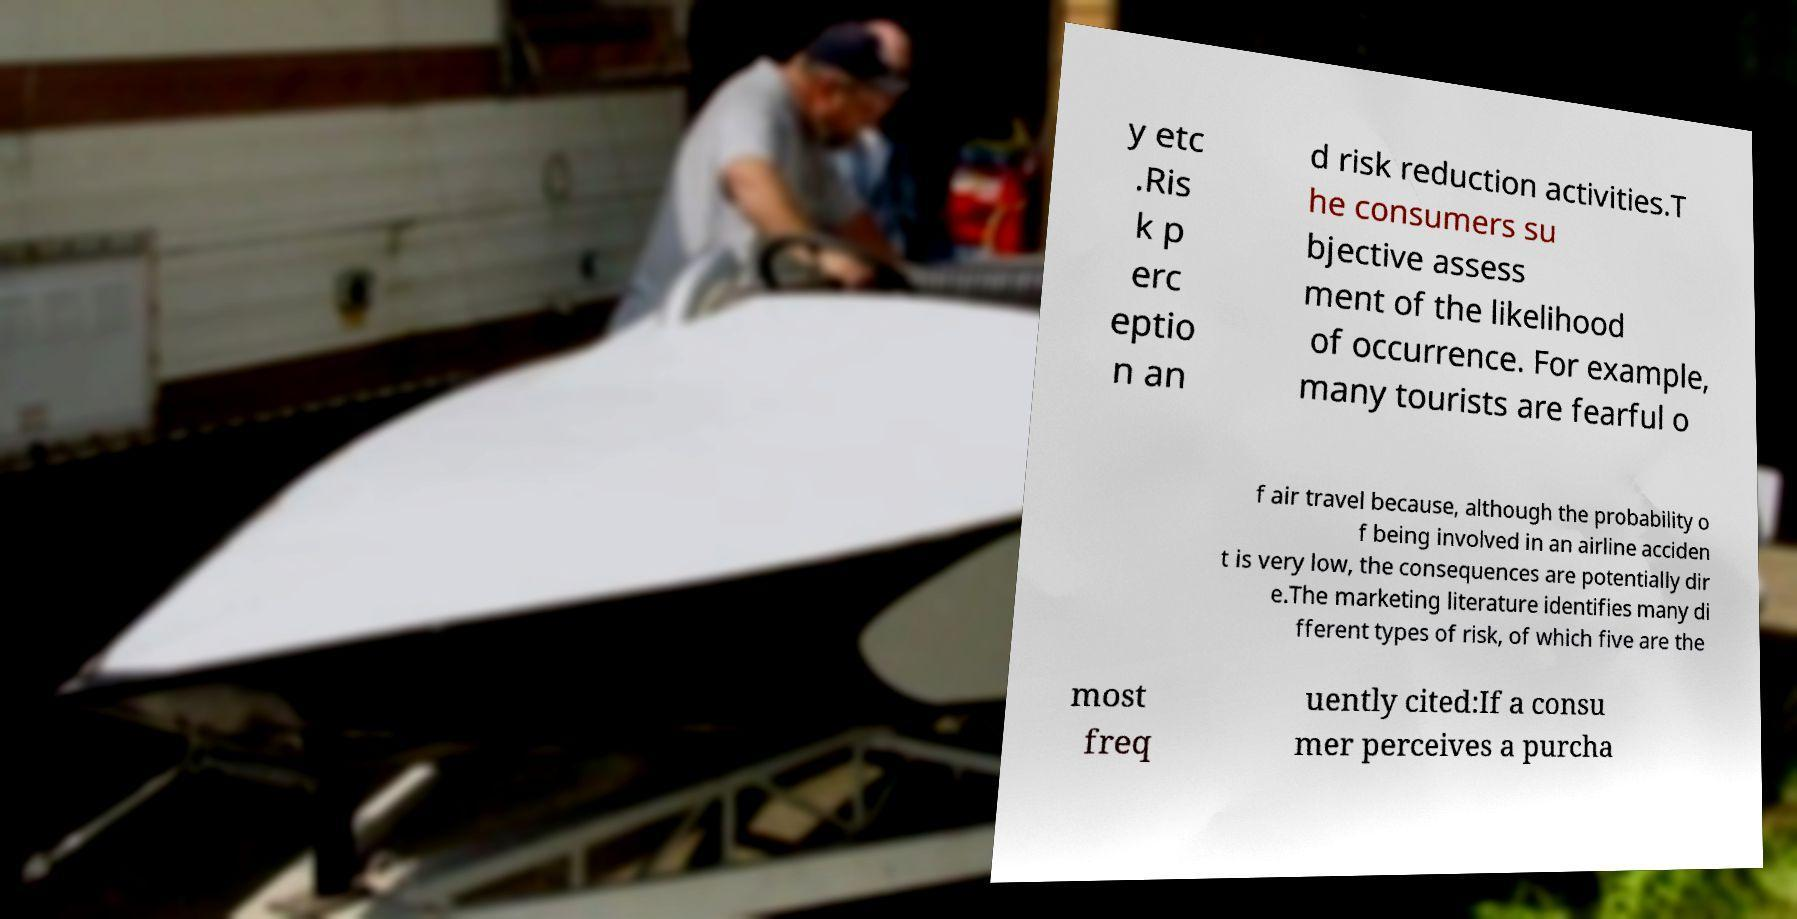Please read and relay the text visible in this image. What does it say? y etc .Ris k p erc eptio n an d risk reduction activities.T he consumers su bjective assess ment of the likelihood of occurrence. For example, many tourists are fearful o f air travel because, although the probability o f being involved in an airline acciden t is very low, the consequences are potentially dir e.The marketing literature identifies many di fferent types of risk, of which five are the most freq uently cited:If a consu mer perceives a purcha 